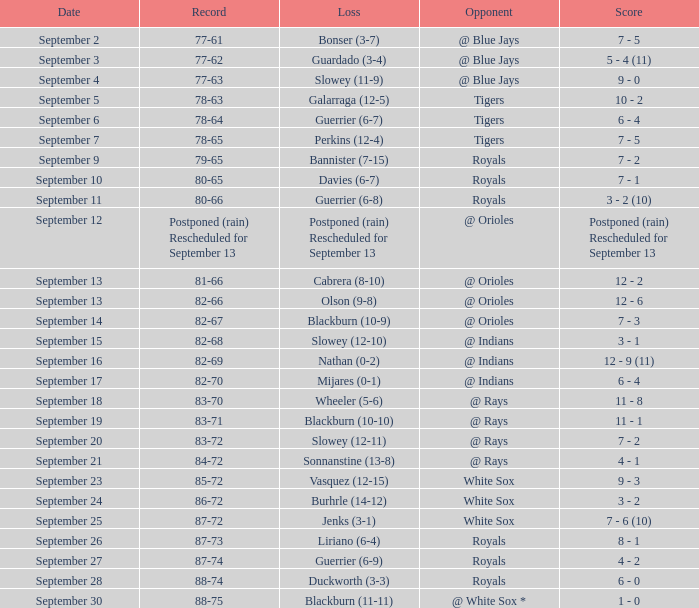What date has the record of 77-62? September 3. 